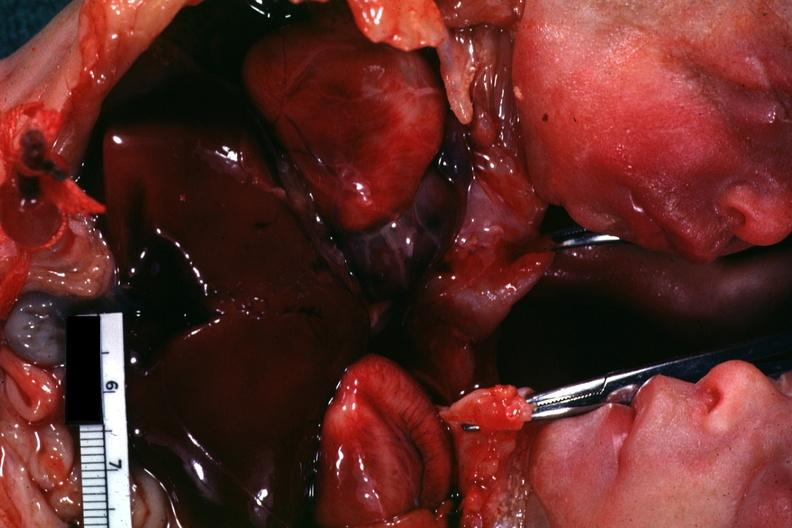what shows opened chest with two hearts?
Answer the question using a single word or phrase. Chest and abdomen slide 